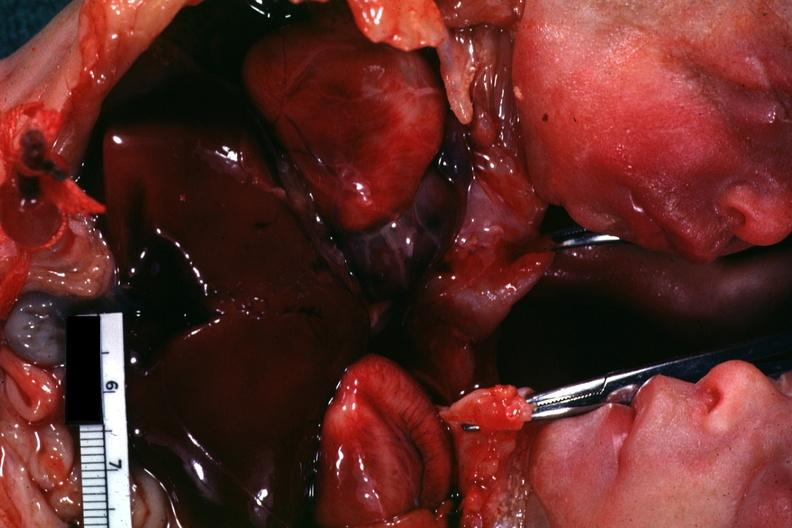what shows opened chest with two hearts?
Answer the question using a single word or phrase. Chest and abdomen slide 